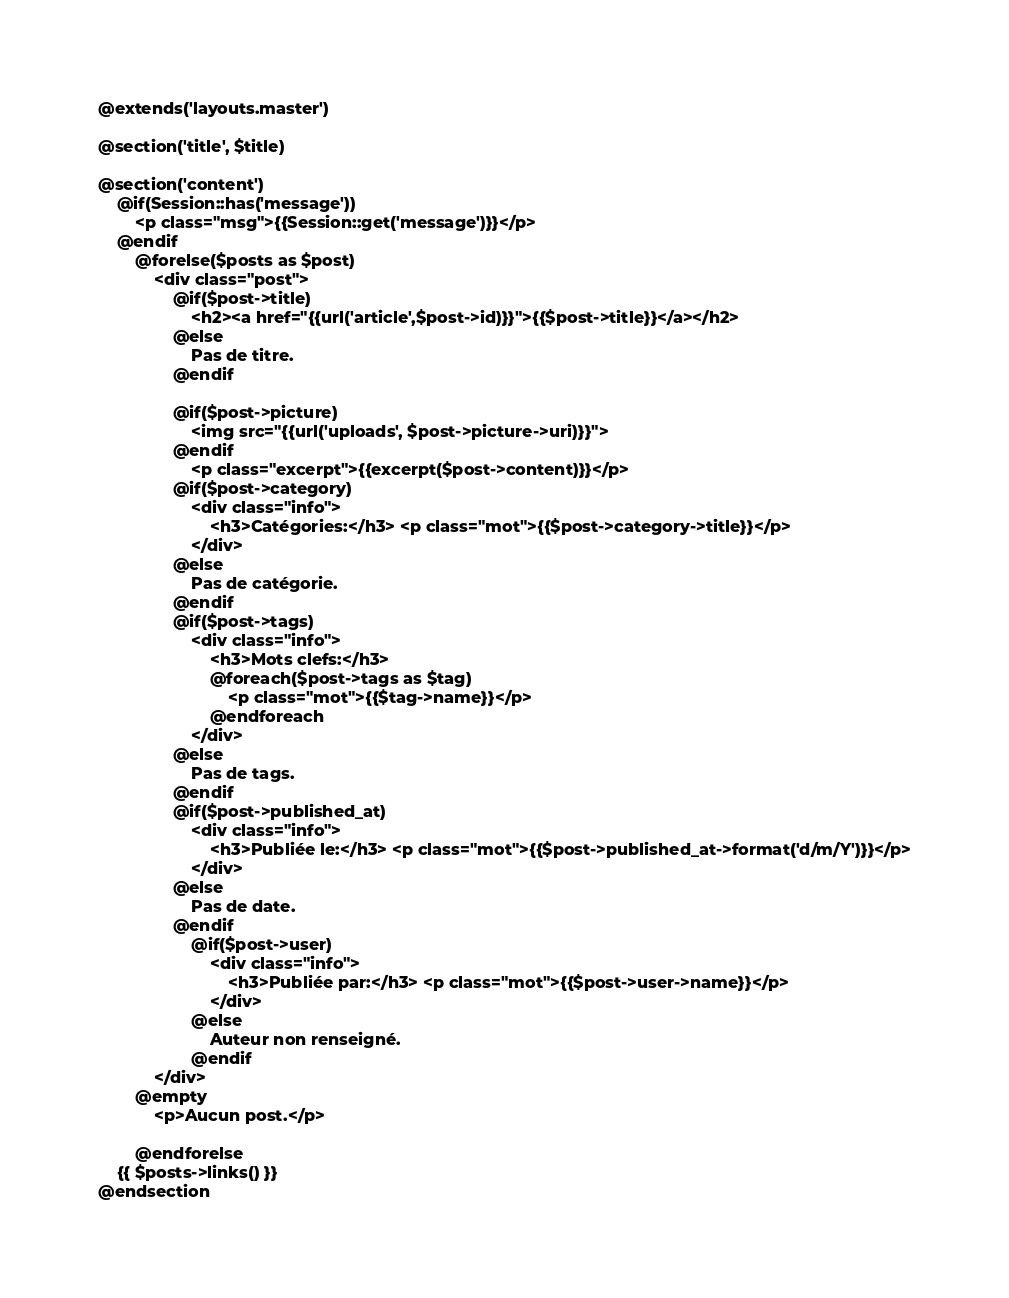Convert code to text. <code><loc_0><loc_0><loc_500><loc_500><_PHP_>@extends('layouts.master')

@section('title', $title)

@section('content')
    @if(Session::has('message'))
        <p class="msg">{{Session::get('message')}}</p>
    @endif
        @forelse($posts as $post)
            <div class="post">
                @if($post->title)
                    <h2><a href="{{url('article',$post->id)}}">{{$post->title}}</a></h2>
                @else
                    Pas de titre.
                @endif

                @if($post->picture)
                    <img src="{{url('uploads', $post->picture->uri)}}">
                @endif
                    <p class="excerpt">{{excerpt($post->content)}}</p>
                @if($post->category)
                    <div class="info">
                        <h3>Catégories:</h3> <p class="mot">{{$post->category->title}}</p>
                    </div>
                @else
                    Pas de catégorie.
                @endif
                @if($post->tags)
                    <div class="info">
                        <h3>Mots clefs:</h3>
                        @foreach($post->tags as $tag)
                            <p class="mot">{{$tag->name}}</p>
                        @endforeach
                    </div>
                @else
                    Pas de tags.
                @endif
                @if($post->published_at)
                    <div class="info">
                        <h3>Publiée le:</h3> <p class="mot">{{$post->published_at->format('d/m/Y')}}</p>
                    </div>
                @else
                    Pas de date.
                @endif
                    @if($post->user)
                        <div class="info">
                            <h3>Publiée par:</h3> <p class="mot">{{$post->user->name}}</p>
                        </div>
                    @else
                        Auteur non renseigné.
                    @endif
            </div>
        @empty
            <p>Aucun post.</p>

        @endforelse
    {{ $posts->links() }}
@endsection</code> 